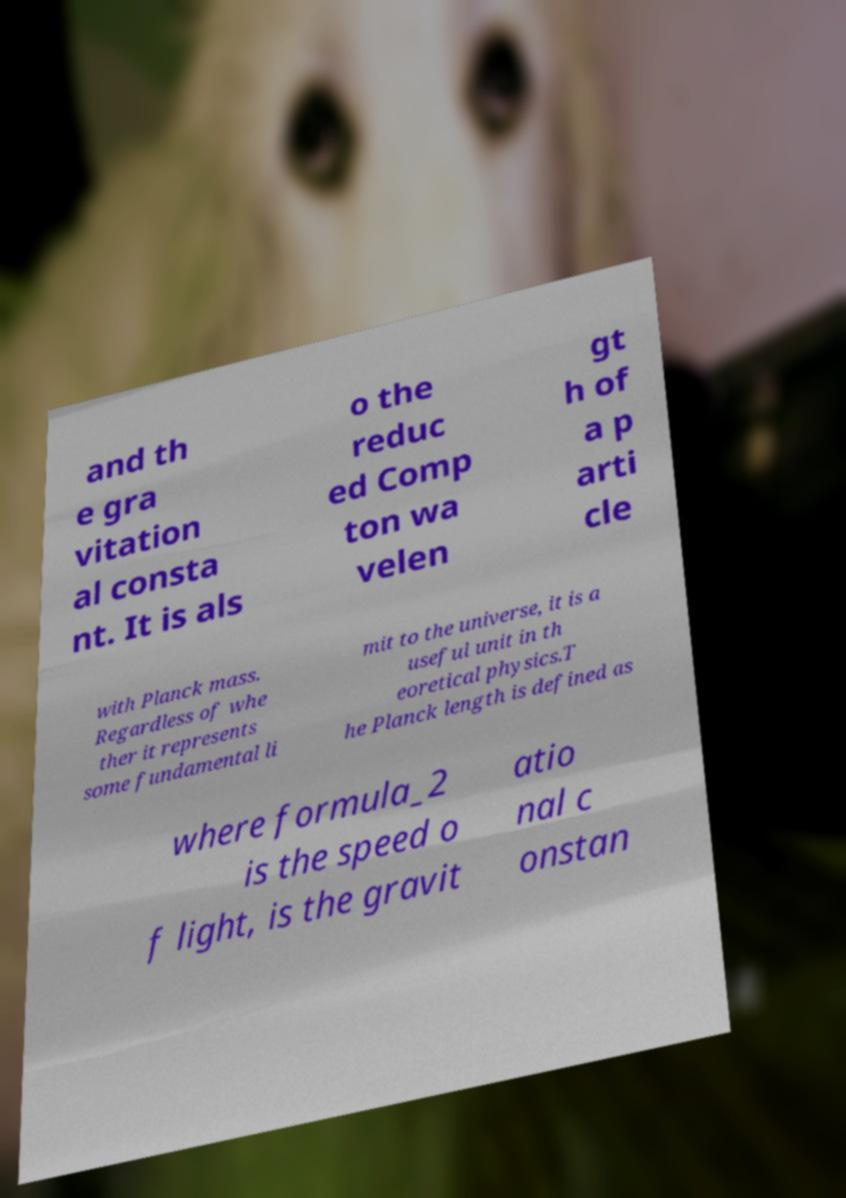Could you extract and type out the text from this image? and th e gra vitation al consta nt. It is als o the reduc ed Comp ton wa velen gt h of a p arti cle with Planck mass. Regardless of whe ther it represents some fundamental li mit to the universe, it is a useful unit in th eoretical physics.T he Planck length is defined as where formula_2 is the speed o f light, is the gravit atio nal c onstan 